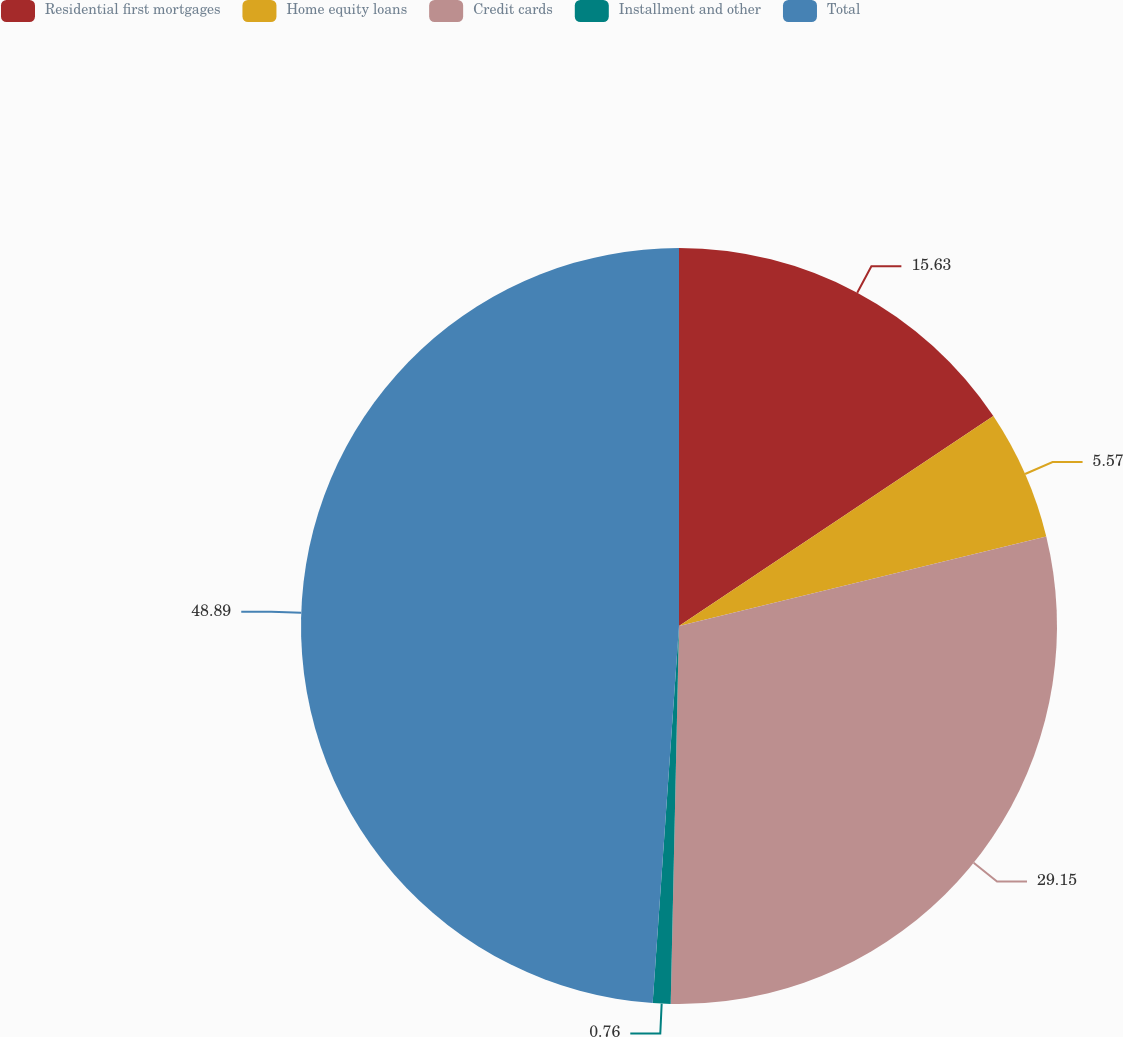Convert chart to OTSL. <chart><loc_0><loc_0><loc_500><loc_500><pie_chart><fcel>Residential first mortgages<fcel>Home equity loans<fcel>Credit cards<fcel>Installment and other<fcel>Total<nl><fcel>15.63%<fcel>5.57%<fcel>29.15%<fcel>0.76%<fcel>48.89%<nl></chart> 